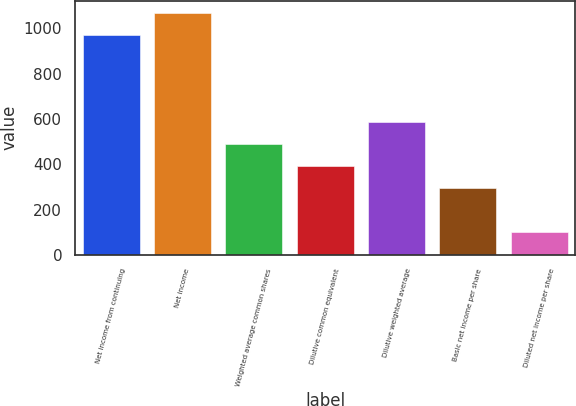<chart> <loc_0><loc_0><loc_500><loc_500><bar_chart><fcel>Net income from continuing<fcel>Net income<fcel>Weighted average common shares<fcel>Dilutive common equivalent<fcel>Dilutive weighted average<fcel>Basic net income per share<fcel>Diluted net income per share<nl><fcel>971<fcel>1067.73<fcel>487.37<fcel>390.64<fcel>584.1<fcel>293.91<fcel>100.45<nl></chart> 